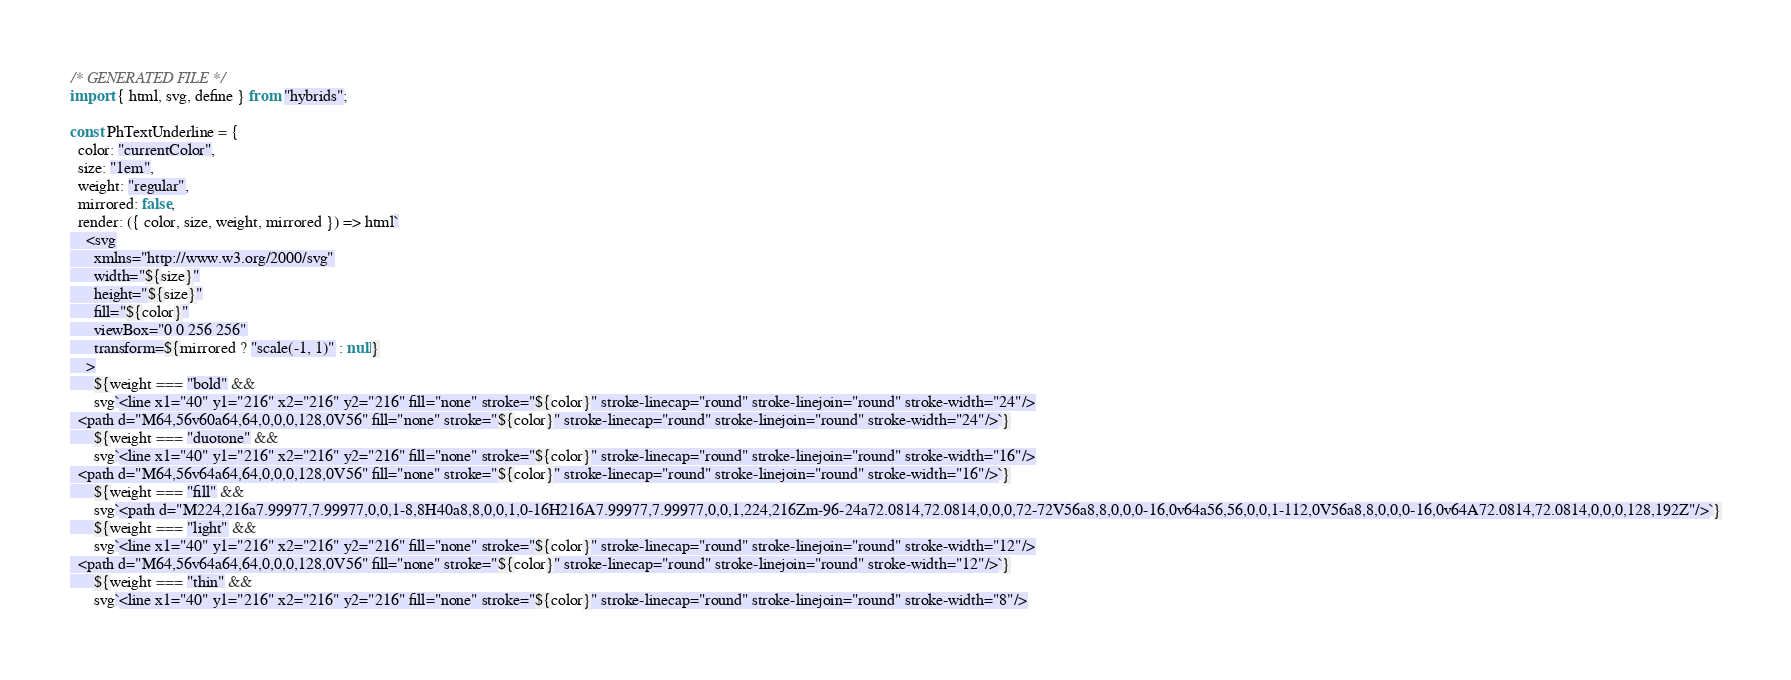<code> <loc_0><loc_0><loc_500><loc_500><_JavaScript_>/* GENERATED FILE */
import { html, svg, define } from "hybrids";

const PhTextUnderline = {
  color: "currentColor",
  size: "1em",
  weight: "regular",
  mirrored: false,
  render: ({ color, size, weight, mirrored }) => html`
    <svg
      xmlns="http://www.w3.org/2000/svg"
      width="${size}"
      height="${size}"
      fill="${color}"
      viewBox="0 0 256 256"
      transform=${mirrored ? "scale(-1, 1)" : null}
    >
      ${weight === "bold" &&
      svg`<line x1="40" y1="216" x2="216" y2="216" fill="none" stroke="${color}" stroke-linecap="round" stroke-linejoin="round" stroke-width="24"/>
  <path d="M64,56v60a64,64,0,0,0,128,0V56" fill="none" stroke="${color}" stroke-linecap="round" stroke-linejoin="round" stroke-width="24"/>`}
      ${weight === "duotone" &&
      svg`<line x1="40" y1="216" x2="216" y2="216" fill="none" stroke="${color}" stroke-linecap="round" stroke-linejoin="round" stroke-width="16"/>
  <path d="M64,56v64a64,64,0,0,0,128,0V56" fill="none" stroke="${color}" stroke-linecap="round" stroke-linejoin="round" stroke-width="16"/>`}
      ${weight === "fill" &&
      svg`<path d="M224,216a7.99977,7.99977,0,0,1-8,8H40a8,8,0,0,1,0-16H216A7.99977,7.99977,0,0,1,224,216Zm-96-24a72.0814,72.0814,0,0,0,72-72V56a8,8,0,0,0-16,0v64a56,56,0,0,1-112,0V56a8,8,0,0,0-16,0v64A72.0814,72.0814,0,0,0,128,192Z"/>`}
      ${weight === "light" &&
      svg`<line x1="40" y1="216" x2="216" y2="216" fill="none" stroke="${color}" stroke-linecap="round" stroke-linejoin="round" stroke-width="12"/>
  <path d="M64,56v64a64,64,0,0,0,128,0V56" fill="none" stroke="${color}" stroke-linecap="round" stroke-linejoin="round" stroke-width="12"/>`}
      ${weight === "thin" &&
      svg`<line x1="40" y1="216" x2="216" y2="216" fill="none" stroke="${color}" stroke-linecap="round" stroke-linejoin="round" stroke-width="8"/></code> 